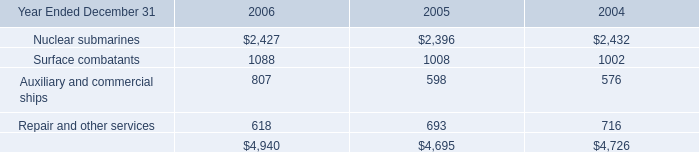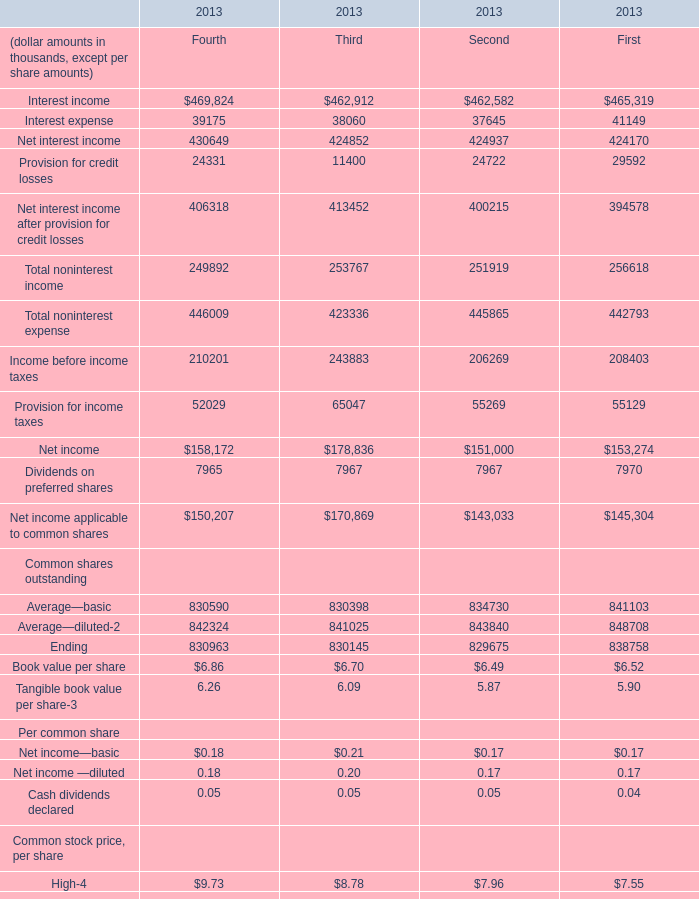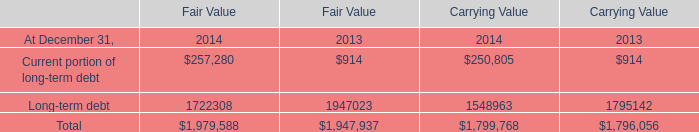What is the sum of Net income—basic,Net income —diluted and Cash dividends declared in 2013 for Second ? (in thousand) 
Computations: ((0.17 + 0.17) + 0.05)
Answer: 0.39. 